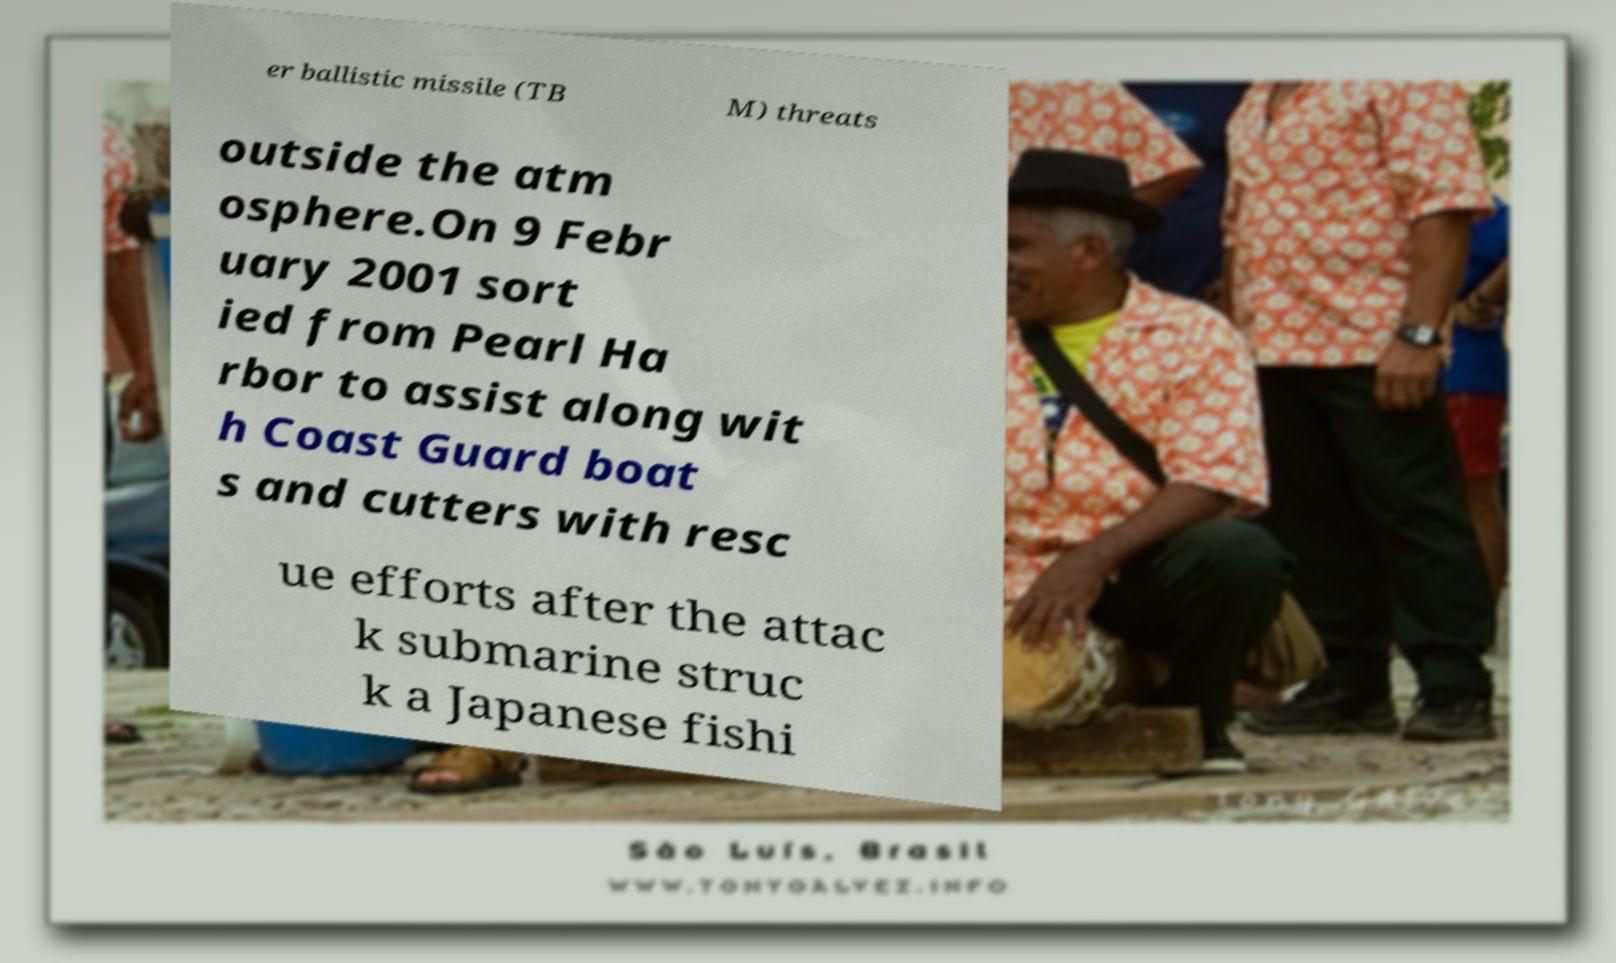Please identify and transcribe the text found in this image. er ballistic missile (TB M) threats outside the atm osphere.On 9 Febr uary 2001 sort ied from Pearl Ha rbor to assist along wit h Coast Guard boat s and cutters with resc ue efforts after the attac k submarine struc k a Japanese fishi 